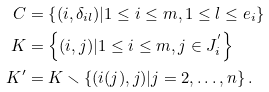<formula> <loc_0><loc_0><loc_500><loc_500>C & = \left \{ ( i , \delta _ { i l } ) | 1 \leq i \leq m , 1 \leq l \leq e _ { i } \right \} \\ K & = \left \{ ( i , j ) | 1 \leq i \leq m , j \in J _ { i } ^ { ^ { \prime } } \right \} \\ K ^ { \prime } & = K \smallsetminus \left \{ ( i ( j ) , j ) | j = 2 , \dots , n \right \} .</formula> 